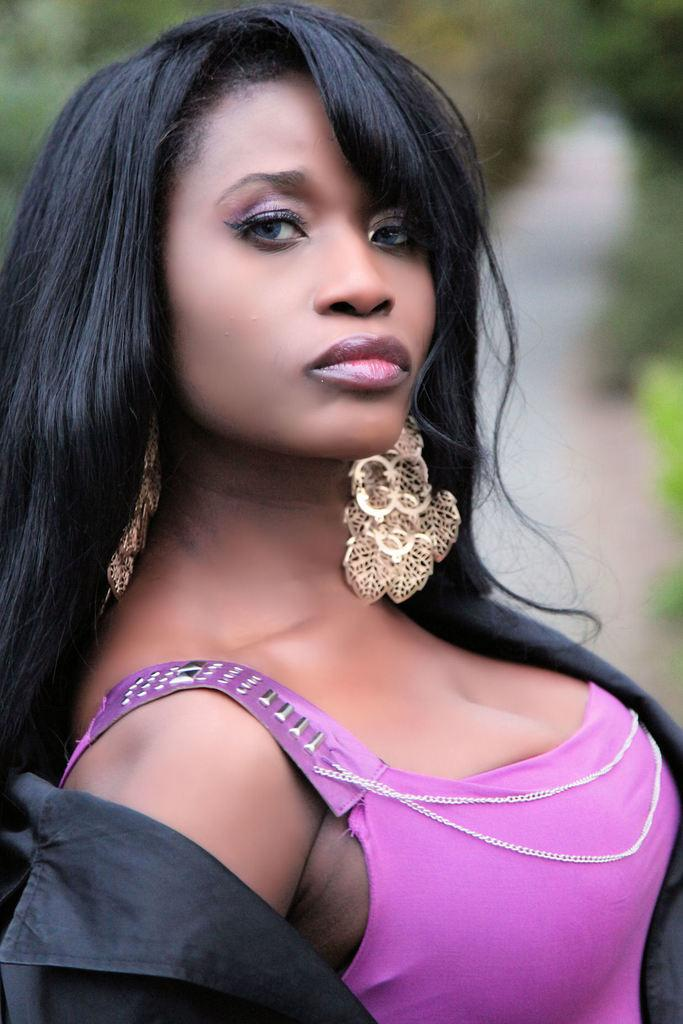Who is the main subject in the image? There is a woman in the image. What is the woman wearing? The woman is wearing a dress and earrings. How is the woman's hair styled in the image? The woman has her hair down. What can be seen in the background of the image? The background of the image is blurry, but a road and trees are visible. What type of leaf is the woman holding in her hand in the image? There is no leaf present in the image; the woman is not holding anything in her hand. What type of woolen garment is the minister wearing in the image? There is no minister present in the image, and therefore no woolen garment can be observed. 